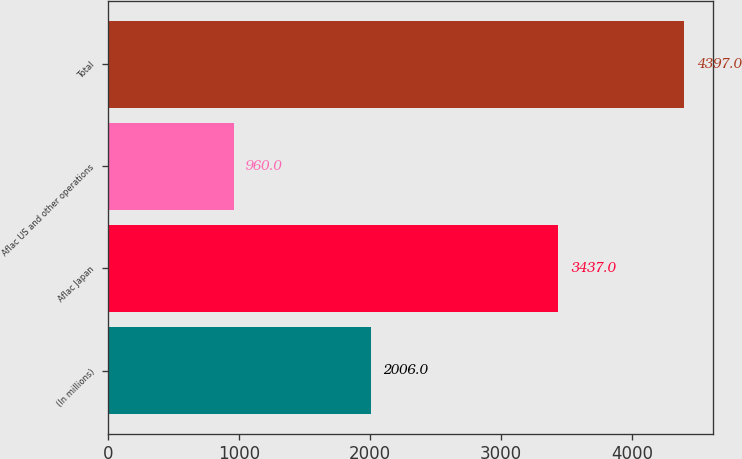Convert chart to OTSL. <chart><loc_0><loc_0><loc_500><loc_500><bar_chart><fcel>(In millions)<fcel>Aflac Japan<fcel>Aflac US and other operations<fcel>Total<nl><fcel>2006<fcel>3437<fcel>960<fcel>4397<nl></chart> 